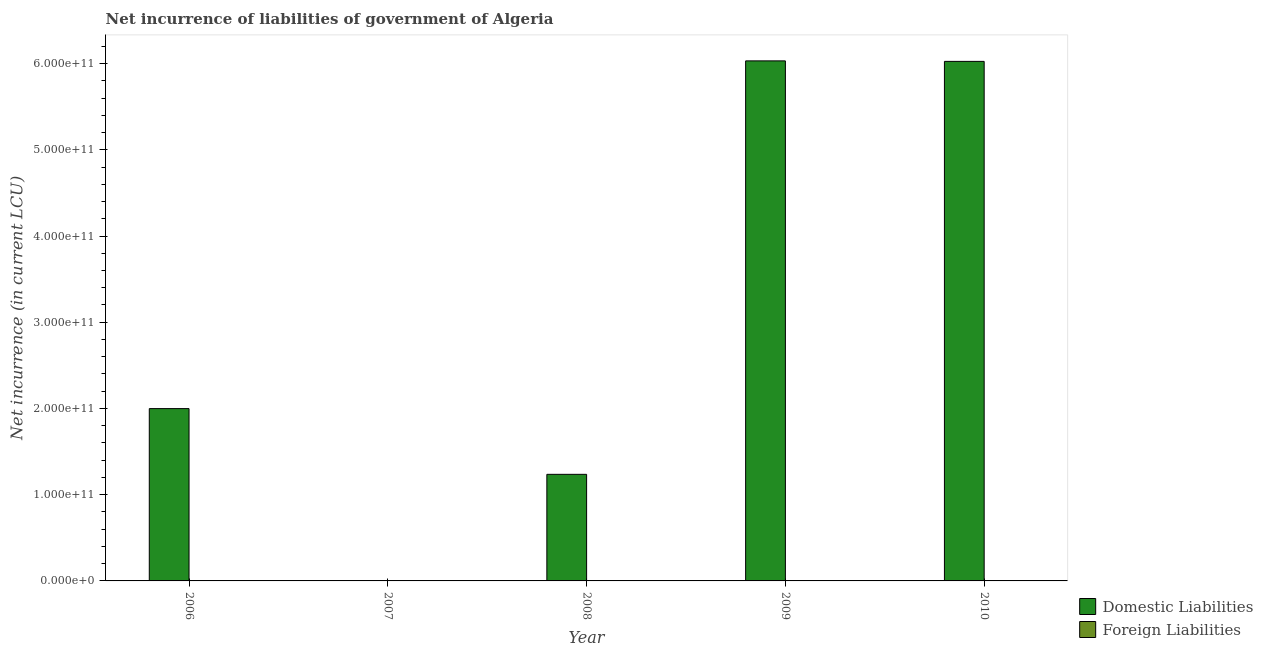Are the number of bars per tick equal to the number of legend labels?
Keep it short and to the point. No. How many bars are there on the 5th tick from the right?
Your answer should be very brief. 1. In how many cases, is the number of bars for a given year not equal to the number of legend labels?
Give a very brief answer. 5. Across all years, what is the maximum net incurrence of domestic liabilities?
Your response must be concise. 6.03e+11. What is the total net incurrence of foreign liabilities in the graph?
Your answer should be very brief. 0. What is the difference between the net incurrence of domestic liabilities in 2008 and that in 2009?
Offer a terse response. -4.79e+11. What is the difference between the net incurrence of foreign liabilities in 2006 and the net incurrence of domestic liabilities in 2007?
Your answer should be very brief. 0. In how many years, is the net incurrence of domestic liabilities greater than 400000000000 LCU?
Your answer should be very brief. 2. What is the ratio of the net incurrence of domestic liabilities in 2006 to that in 2008?
Provide a short and direct response. 1.62. Is the net incurrence of domestic liabilities in 2006 less than that in 2009?
Your answer should be compact. Yes. Is the difference between the net incurrence of domestic liabilities in 2008 and 2010 greater than the difference between the net incurrence of foreign liabilities in 2008 and 2010?
Offer a very short reply. No. What is the difference between the highest and the second highest net incurrence of domestic liabilities?
Your answer should be compact. 5.89e+08. What is the difference between the highest and the lowest net incurrence of domestic liabilities?
Your answer should be very brief. 6.03e+11. Is the sum of the net incurrence of domestic liabilities in 2006 and 2010 greater than the maximum net incurrence of foreign liabilities across all years?
Make the answer very short. Yes. How many bars are there?
Ensure brevity in your answer.  4. How many years are there in the graph?
Your response must be concise. 5. What is the difference between two consecutive major ticks on the Y-axis?
Provide a short and direct response. 1.00e+11. Are the values on the major ticks of Y-axis written in scientific E-notation?
Provide a short and direct response. Yes. Where does the legend appear in the graph?
Your answer should be very brief. Bottom right. How many legend labels are there?
Ensure brevity in your answer.  2. How are the legend labels stacked?
Your answer should be compact. Vertical. What is the title of the graph?
Offer a terse response. Net incurrence of liabilities of government of Algeria. What is the label or title of the Y-axis?
Your answer should be compact. Net incurrence (in current LCU). What is the Net incurrence (in current LCU) in Domestic Liabilities in 2006?
Make the answer very short. 2.00e+11. What is the Net incurrence (in current LCU) in Foreign Liabilities in 2006?
Your answer should be compact. 0. What is the Net incurrence (in current LCU) in Domestic Liabilities in 2008?
Offer a very short reply. 1.24e+11. What is the Net incurrence (in current LCU) in Domestic Liabilities in 2009?
Give a very brief answer. 6.03e+11. What is the Net incurrence (in current LCU) of Domestic Liabilities in 2010?
Offer a very short reply. 6.02e+11. What is the Net incurrence (in current LCU) of Foreign Liabilities in 2010?
Your response must be concise. 0. Across all years, what is the maximum Net incurrence (in current LCU) in Domestic Liabilities?
Make the answer very short. 6.03e+11. Across all years, what is the minimum Net incurrence (in current LCU) of Domestic Liabilities?
Make the answer very short. 0. What is the total Net incurrence (in current LCU) in Domestic Liabilities in the graph?
Your answer should be very brief. 1.53e+12. What is the total Net incurrence (in current LCU) in Foreign Liabilities in the graph?
Offer a terse response. 0. What is the difference between the Net incurrence (in current LCU) in Domestic Liabilities in 2006 and that in 2008?
Provide a short and direct response. 7.62e+1. What is the difference between the Net incurrence (in current LCU) of Domestic Liabilities in 2006 and that in 2009?
Give a very brief answer. -4.03e+11. What is the difference between the Net incurrence (in current LCU) in Domestic Liabilities in 2006 and that in 2010?
Keep it short and to the point. -4.03e+11. What is the difference between the Net incurrence (in current LCU) of Domestic Liabilities in 2008 and that in 2009?
Provide a succinct answer. -4.79e+11. What is the difference between the Net incurrence (in current LCU) in Domestic Liabilities in 2008 and that in 2010?
Provide a succinct answer. -4.79e+11. What is the difference between the Net incurrence (in current LCU) in Domestic Liabilities in 2009 and that in 2010?
Your response must be concise. 5.89e+08. What is the average Net incurrence (in current LCU) of Domestic Liabilities per year?
Offer a terse response. 3.06e+11. What is the average Net incurrence (in current LCU) in Foreign Liabilities per year?
Your response must be concise. 0. What is the ratio of the Net incurrence (in current LCU) in Domestic Liabilities in 2006 to that in 2008?
Provide a succinct answer. 1.62. What is the ratio of the Net incurrence (in current LCU) of Domestic Liabilities in 2006 to that in 2009?
Keep it short and to the point. 0.33. What is the ratio of the Net incurrence (in current LCU) of Domestic Liabilities in 2006 to that in 2010?
Your answer should be very brief. 0.33. What is the ratio of the Net incurrence (in current LCU) of Domestic Liabilities in 2008 to that in 2009?
Make the answer very short. 0.2. What is the ratio of the Net incurrence (in current LCU) of Domestic Liabilities in 2008 to that in 2010?
Give a very brief answer. 0.21. What is the difference between the highest and the second highest Net incurrence (in current LCU) in Domestic Liabilities?
Make the answer very short. 5.89e+08. What is the difference between the highest and the lowest Net incurrence (in current LCU) in Domestic Liabilities?
Offer a very short reply. 6.03e+11. 